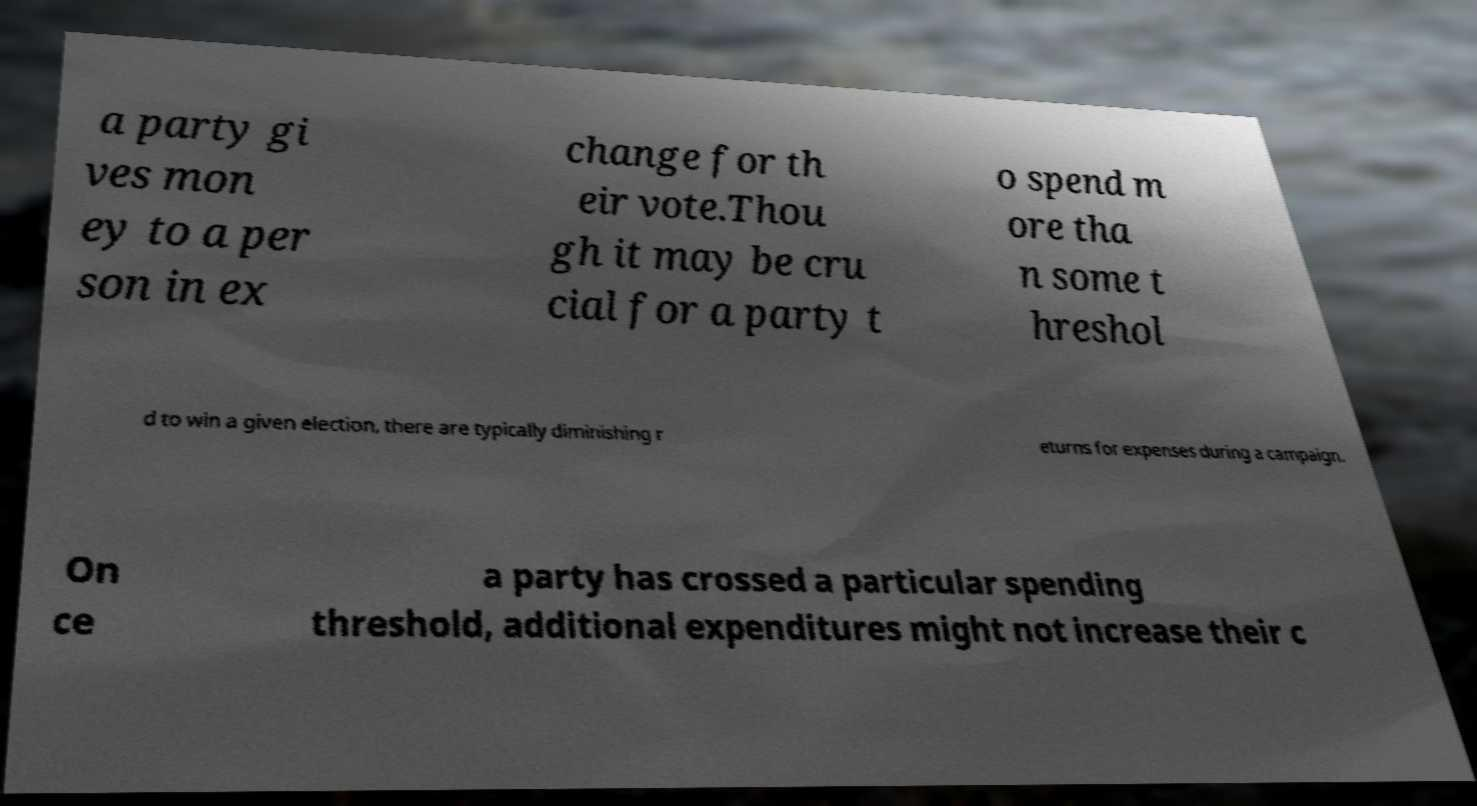Please identify and transcribe the text found in this image. a party gi ves mon ey to a per son in ex change for th eir vote.Thou gh it may be cru cial for a party t o spend m ore tha n some t hreshol d to win a given election, there are typically diminishing r eturns for expenses during a campaign. On ce a party has crossed a particular spending threshold, additional expenditures might not increase their c 